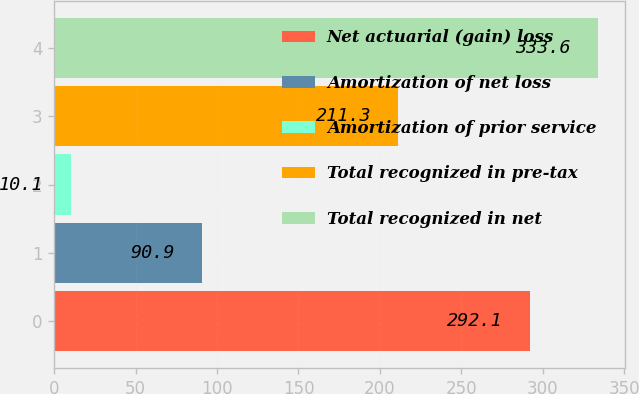<chart> <loc_0><loc_0><loc_500><loc_500><bar_chart><fcel>Net actuarial (gain) loss<fcel>Amortization of net loss<fcel>Amortization of prior service<fcel>Total recognized in pre-tax<fcel>Total recognized in net<nl><fcel>292.1<fcel>90.9<fcel>10.1<fcel>211.3<fcel>333.6<nl></chart> 